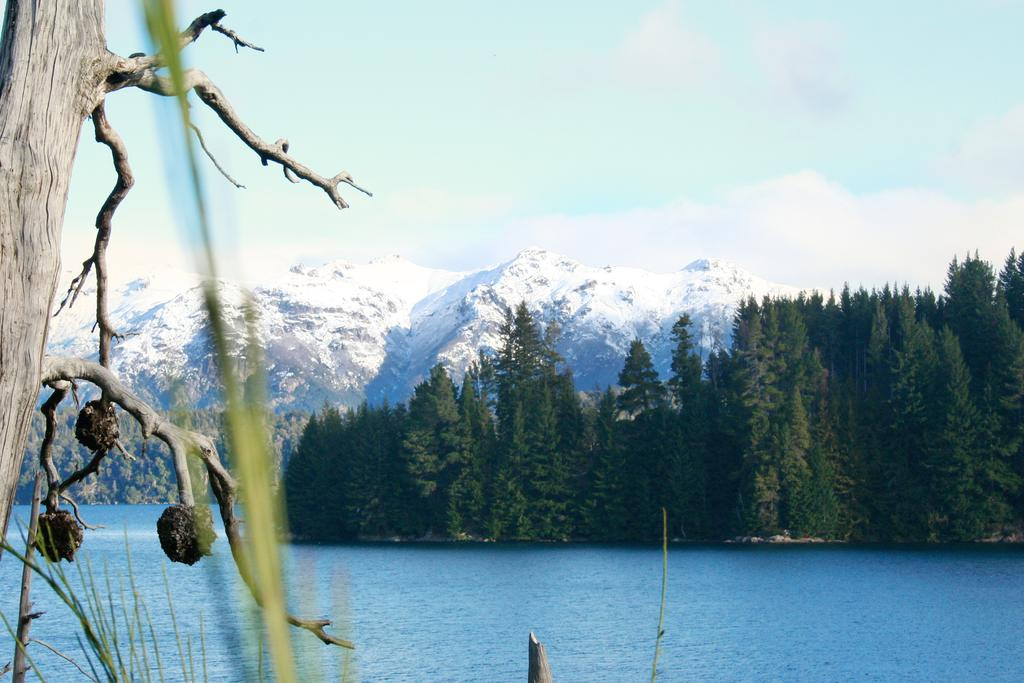What type of vegetation can be seen in the image? There are trees in the image. What geographical feature is visible in the background? There are mountains in the image. What part of the natural environment is visible in the image? The sky is visible in the image. What can be seen in the sky? There are clouds in the sky. What is visible at the bottom of the image? There is water visible at the bottom of the image. Can you tell me how many dogs are playing with a cloth in the image? There are no dogs or cloth present in the image. What type of spring is visible in the image? There is no spring present in the image. 